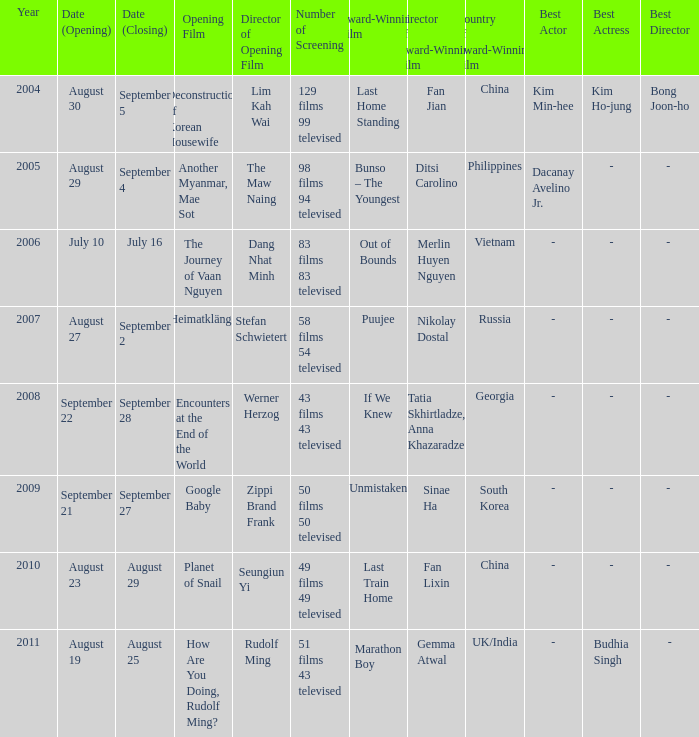Which opening film has the opening date of august 23? Planet of Snail. 